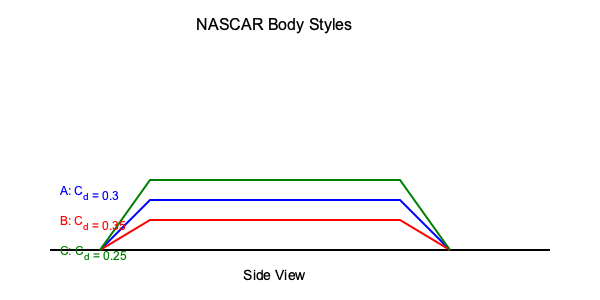The diagram shows three different NASCAR body styles (A, B, and C) with their respective drag coefficients (C<sub>d</sub>). If all other factors are equal, which body style would likely achieve the highest top speed on a straightaway, and by what percentage would it outperform the slowest design? Assume the relationship between drag force and velocity is given by $F_d = \frac{1}{2}\rho v^2 C_d A$, where $\rho$ is air density and $A$ is frontal area. To solve this problem, we need to follow these steps:

1. Identify the body style with the lowest drag coefficient, as this will achieve the highest top speed.

Body style C has the lowest C<sub>d</sub> of 0.25, so it will achieve the highest top speed.

2. Identify the body style with the highest drag coefficient, as this will be the slowest.

Body style B has the highest C<sub>d</sub> of 0.35, so it will be the slowest.

3. Calculate the percentage difference in top speed between these two designs.

At top speed, the drag force equals the engine's maximum thrust. We can set up this equation:

$F_{max} = \frac{1}{2}\rho v^2 C_d A$

Rearranging for velocity:

$v = \sqrt{\frac{2F_{max}}{\rho C_d A}}$

The ratio of top speeds will be:

$\frac{v_C}{v_B} = \sqrt{\frac{C_{d,B}}{C_{d,C}}} = \sqrt{\frac{0.35}{0.25}} \approx 1.1832$

This means body style C will be approximately 18.32% faster than body style B.

4. Convert this to a percentage difference:

Percentage difference = (1.1832 - 1) * 100% = 18.32%
Answer: Body style C; 18.32% faster 